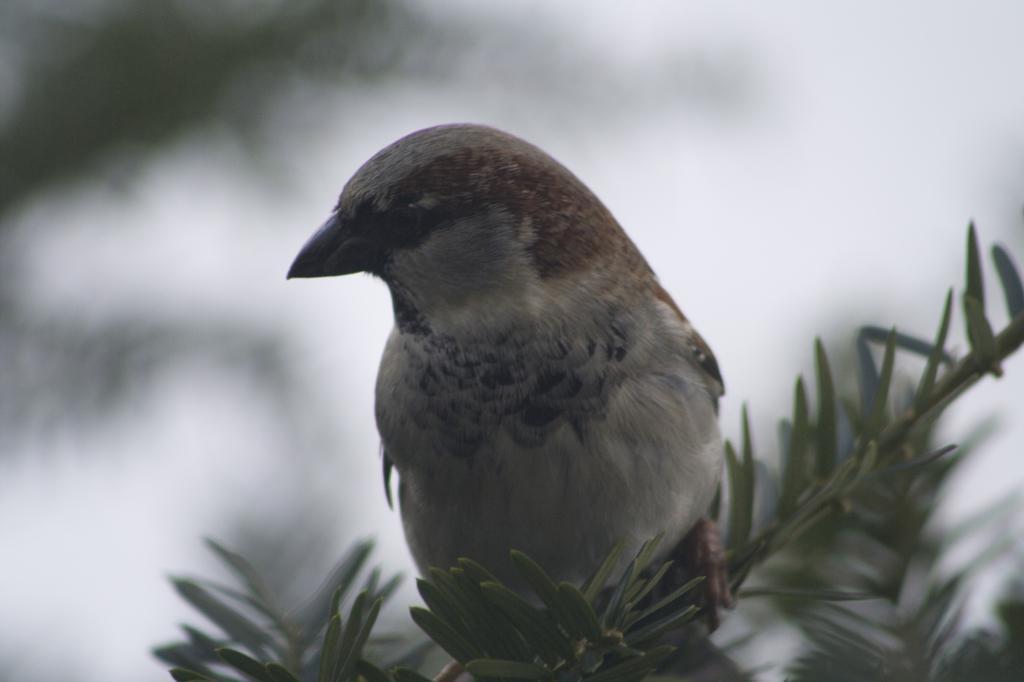Could you give a brief overview of what you see in this image? In this image, we can see a bird. There are some leaves at the bottom of the image. In the background, image is blurred. 